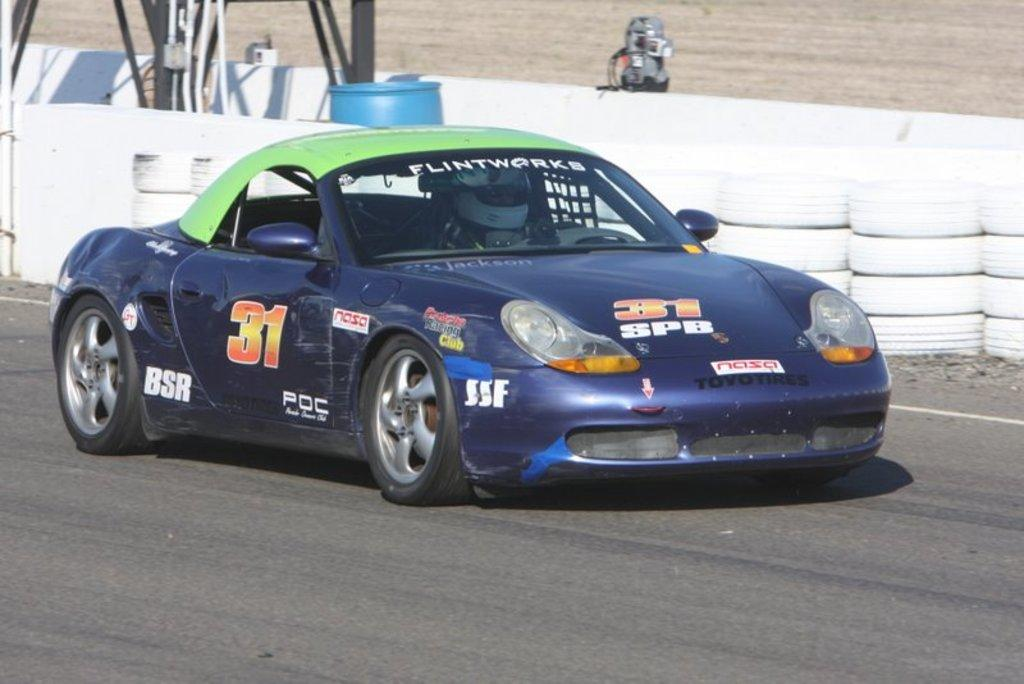What is the main subject of the image? There is a car in the image. Where is the car located? The car is on the road. Can you describe the interior of the car? There is a person inside the car. What can be seen in the background of the image? There are tires and a drum visible in the background. What type of paper is being used by the person inside the car? There is no paper visible in the image, and it is not mentioned that the person inside the car is using any paper. 